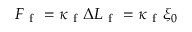<formula> <loc_0><loc_0><loc_500><loc_500>F _ { f } = \kappa _ { f } \Delta L _ { f } = \kappa _ { f } \xi _ { 0 }</formula> 